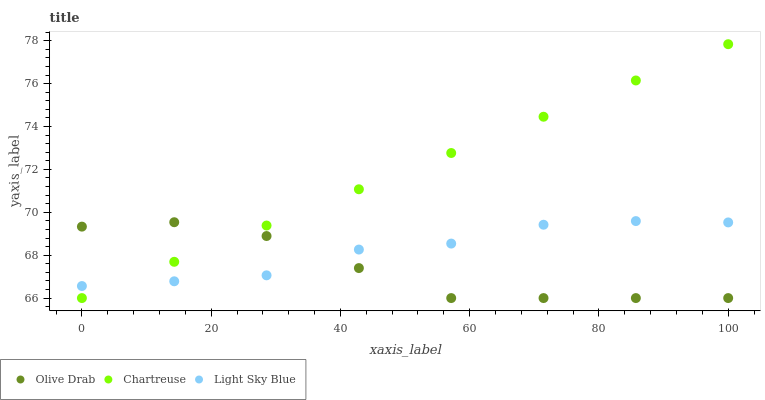Does Olive Drab have the minimum area under the curve?
Answer yes or no. Yes. Does Chartreuse have the maximum area under the curve?
Answer yes or no. Yes. Does Light Sky Blue have the minimum area under the curve?
Answer yes or no. No. Does Light Sky Blue have the maximum area under the curve?
Answer yes or no. No. Is Chartreuse the smoothest?
Answer yes or no. Yes. Is Light Sky Blue the roughest?
Answer yes or no. Yes. Is Olive Drab the smoothest?
Answer yes or no. No. Is Olive Drab the roughest?
Answer yes or no. No. Does Chartreuse have the lowest value?
Answer yes or no. Yes. Does Light Sky Blue have the lowest value?
Answer yes or no. No. Does Chartreuse have the highest value?
Answer yes or no. Yes. Does Light Sky Blue have the highest value?
Answer yes or no. No. Does Light Sky Blue intersect Olive Drab?
Answer yes or no. Yes. Is Light Sky Blue less than Olive Drab?
Answer yes or no. No. Is Light Sky Blue greater than Olive Drab?
Answer yes or no. No. 